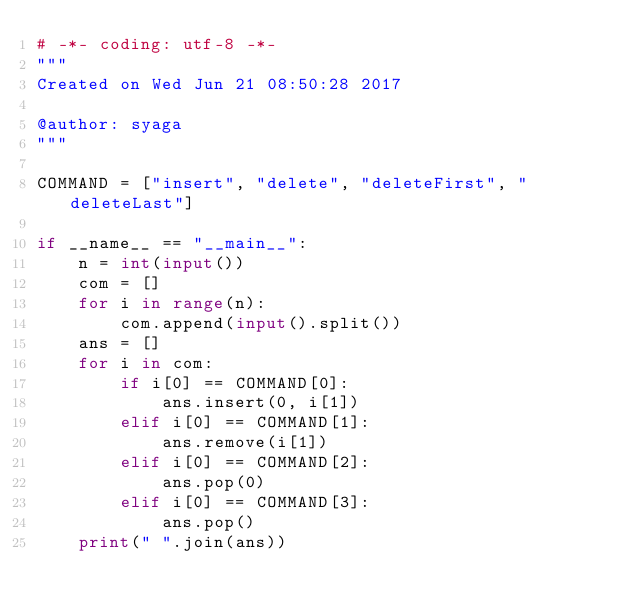<code> <loc_0><loc_0><loc_500><loc_500><_Python_># -*- coding: utf-8 -*-
"""
Created on Wed Jun 21 08:50:28 2017

@author: syaga
"""

COMMAND = ["insert", "delete", "deleteFirst", "deleteLast"]

if __name__ == "__main__":
    n = int(input())
    com = []
    for i in range(n):
        com.append(input().split())
    ans = []
    for i in com:
        if i[0] == COMMAND[0]:
            ans.insert(0, i[1])
        elif i[0] == COMMAND[1]:
            ans.remove(i[1])
        elif i[0] == COMMAND[2]:
            ans.pop(0)
        elif i[0] == COMMAND[3]:
            ans.pop()
    print(" ".join(ans))</code> 